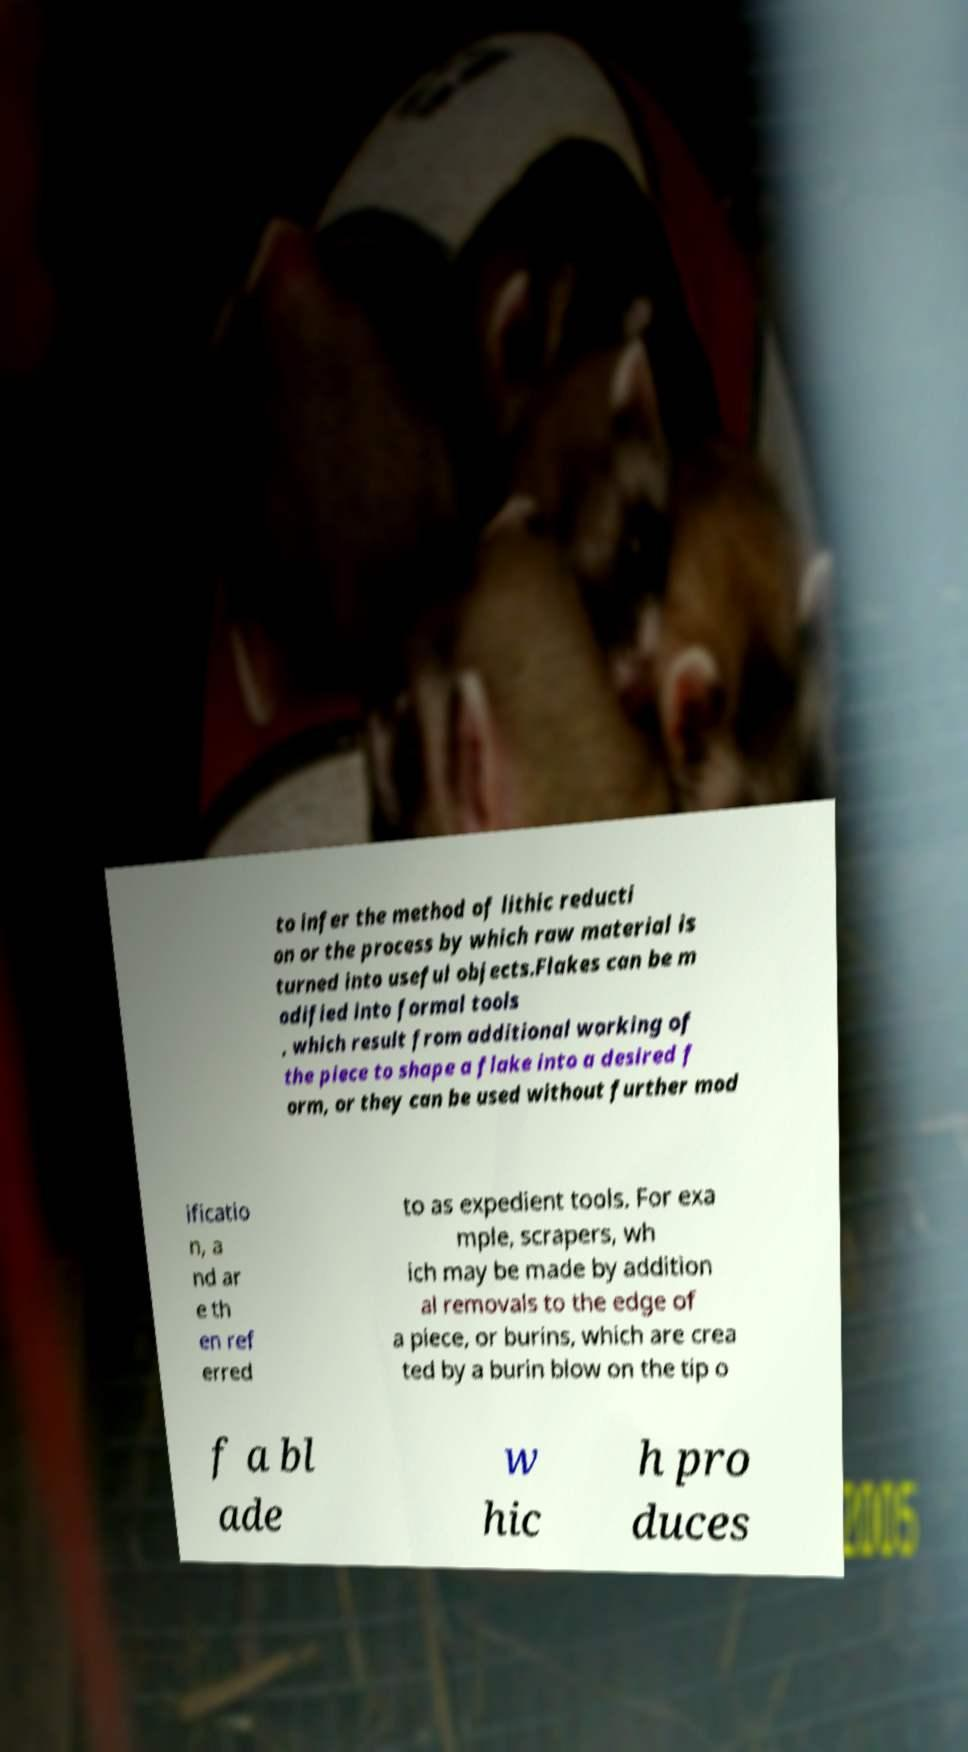Can you read and provide the text displayed in the image?This photo seems to have some interesting text. Can you extract and type it out for me? to infer the method of lithic reducti on or the process by which raw material is turned into useful objects.Flakes can be m odified into formal tools , which result from additional working of the piece to shape a flake into a desired f orm, or they can be used without further mod ificatio n, a nd ar e th en ref erred to as expedient tools. For exa mple, scrapers, wh ich may be made by addition al removals to the edge of a piece, or burins, which are crea ted by a burin blow on the tip o f a bl ade w hic h pro duces 